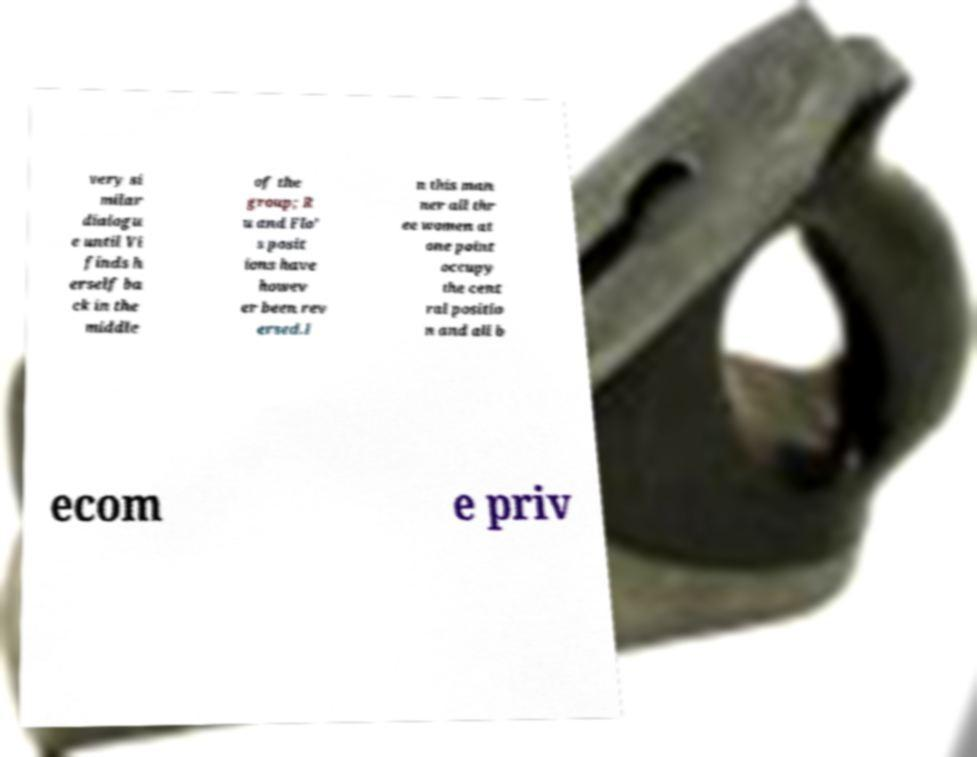What messages or text are displayed in this image? I need them in a readable, typed format. very si milar dialogu e until Vi finds h erself ba ck in the middle of the group; R u and Flo' s posit ions have howev er been rev ersed.I n this man ner all thr ee women at one point occupy the cent ral positio n and all b ecom e priv 